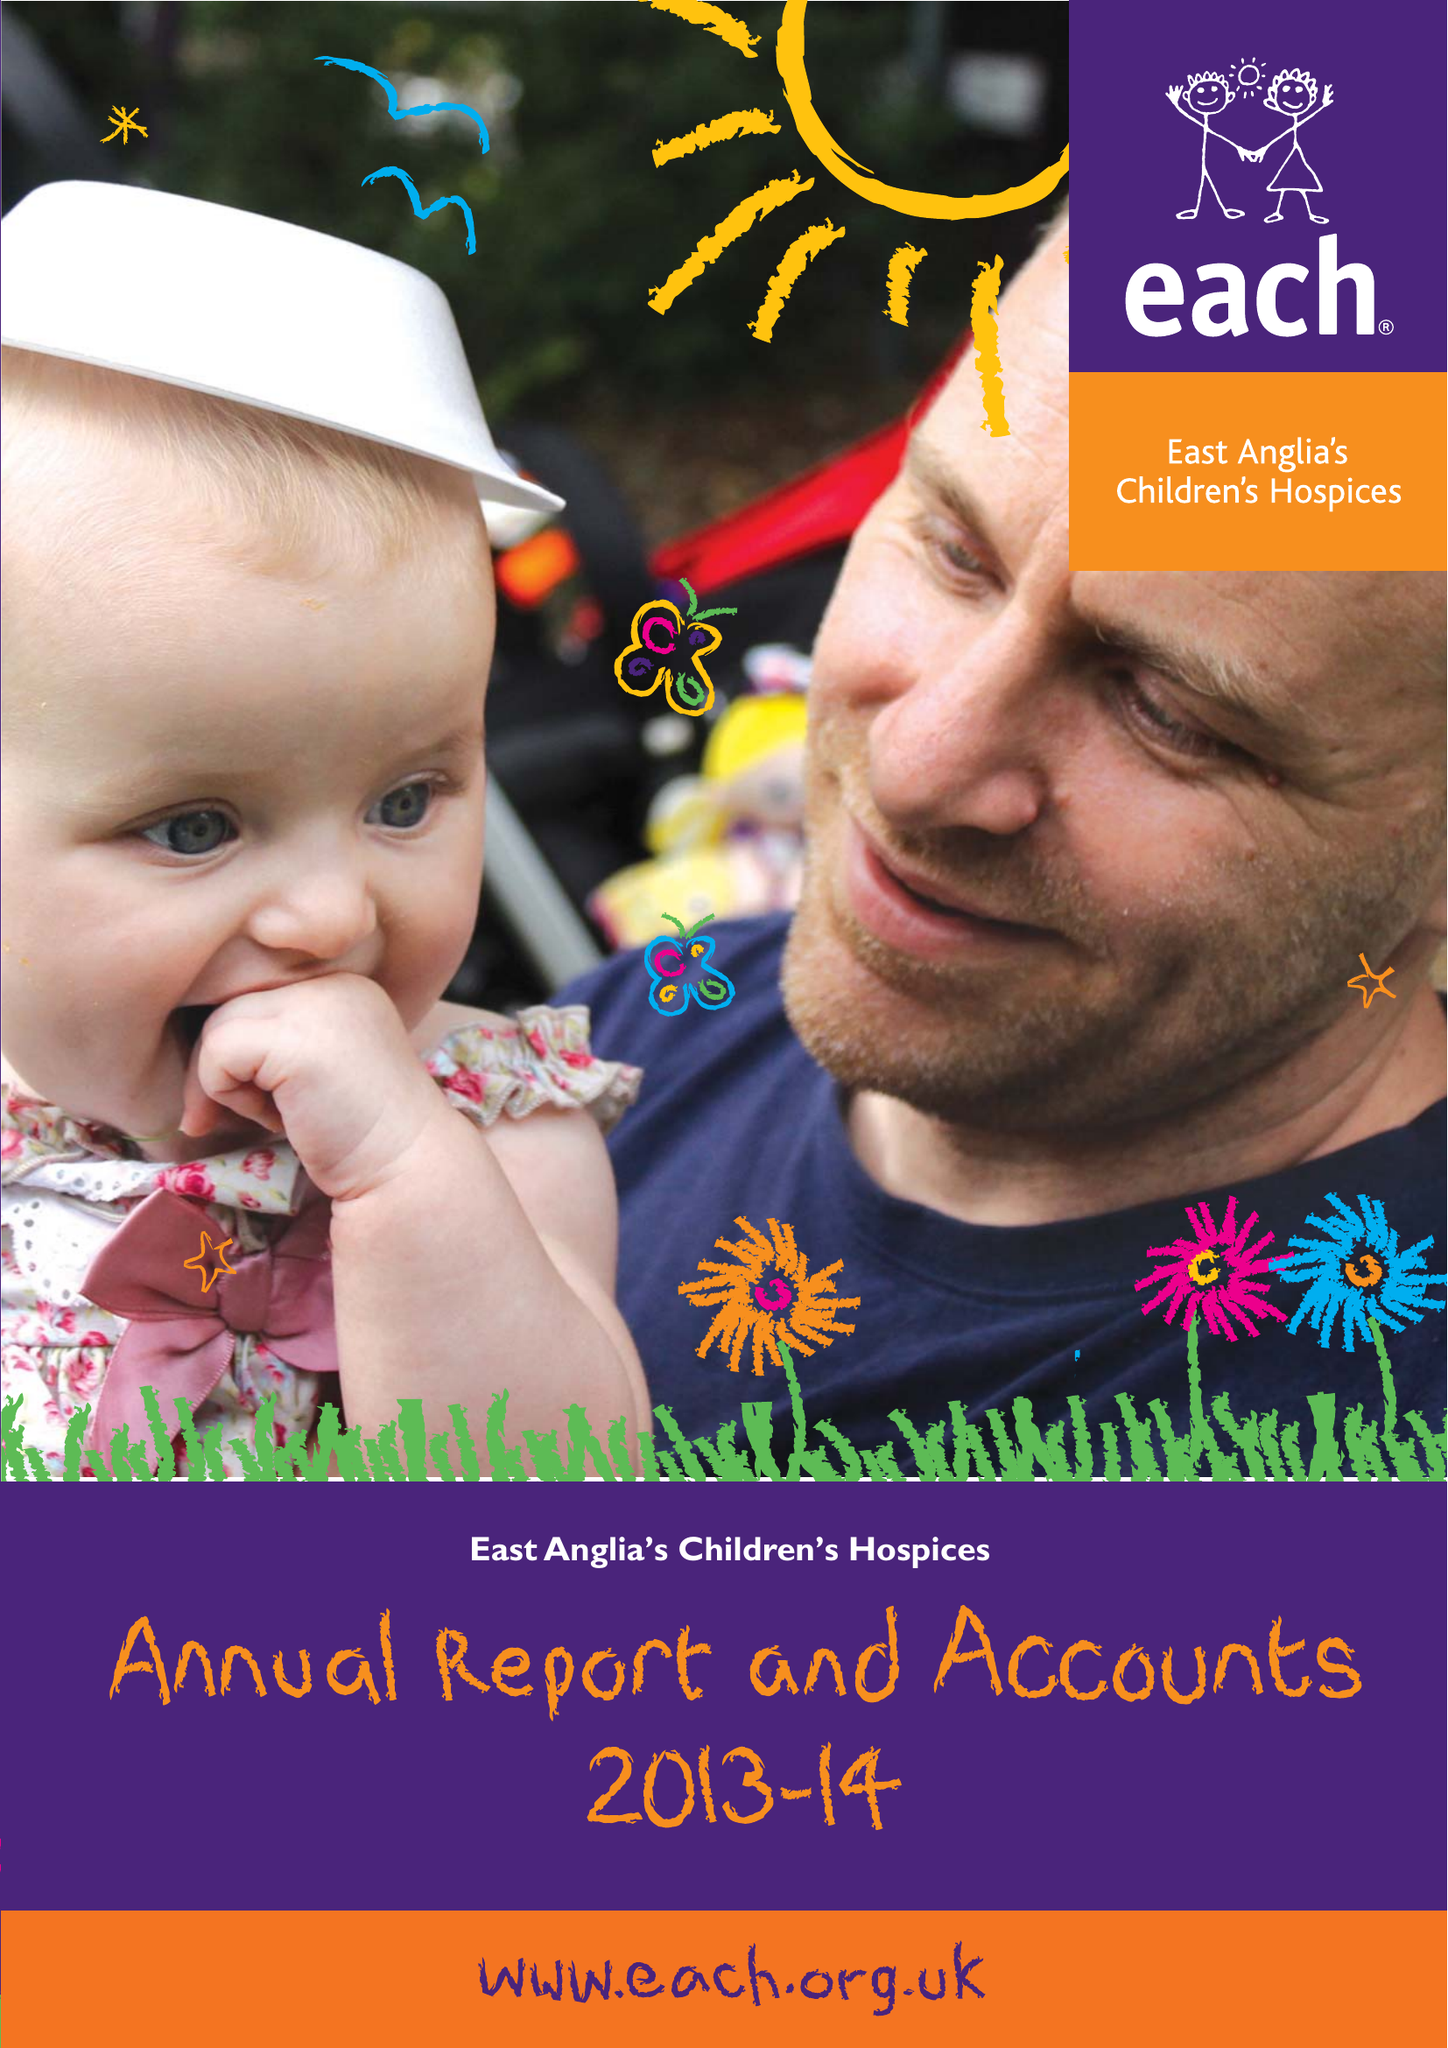What is the value for the report_date?
Answer the question using a single word or phrase. 2014-03-31 